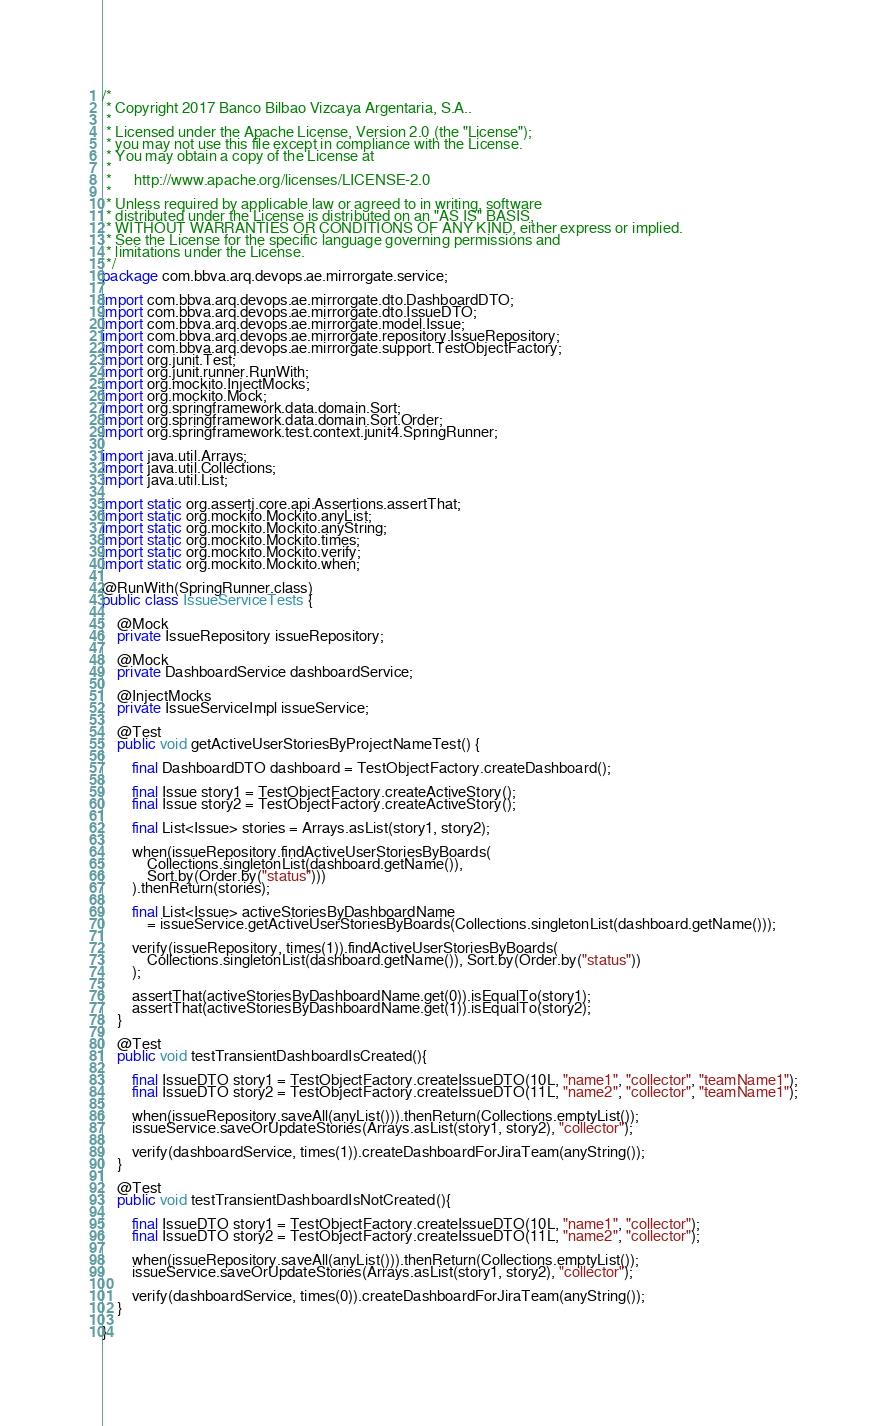<code> <loc_0><loc_0><loc_500><loc_500><_Java_>/*
 * Copyright 2017 Banco Bilbao Vizcaya Argentaria, S.A..
 *
 * Licensed under the Apache License, Version 2.0 (the "License");
 * you may not use this file except in compliance with the License.
 * You may obtain a copy of the License at
 *
 *      http://www.apache.org/licenses/LICENSE-2.0
 *
 * Unless required by applicable law or agreed to in writing, software
 * distributed under the License is distributed on an "AS IS" BASIS,
 * WITHOUT WARRANTIES OR CONDITIONS OF ANY KIND, either express or implied.
 * See the License for the specific language governing permissions and
 * limitations under the License.
 */
package com.bbva.arq.devops.ae.mirrorgate.service;

import com.bbva.arq.devops.ae.mirrorgate.dto.DashboardDTO;
import com.bbva.arq.devops.ae.mirrorgate.dto.IssueDTO;
import com.bbva.arq.devops.ae.mirrorgate.model.Issue;
import com.bbva.arq.devops.ae.mirrorgate.repository.IssueRepository;
import com.bbva.arq.devops.ae.mirrorgate.support.TestObjectFactory;
import org.junit.Test;
import org.junit.runner.RunWith;
import org.mockito.InjectMocks;
import org.mockito.Mock;
import org.springframework.data.domain.Sort;
import org.springframework.data.domain.Sort.Order;
import org.springframework.test.context.junit4.SpringRunner;

import java.util.Arrays;
import java.util.Collections;
import java.util.List;

import static org.assertj.core.api.Assertions.assertThat;
import static org.mockito.Mockito.anyList;
import static org.mockito.Mockito.anyString;
import static org.mockito.Mockito.times;
import static org.mockito.Mockito.verify;
import static org.mockito.Mockito.when;

@RunWith(SpringRunner.class)
public class IssueServiceTests {

    @Mock
    private IssueRepository issueRepository;

    @Mock
    private DashboardService dashboardService;

    @InjectMocks
    private IssueServiceImpl issueService;

    @Test
    public void getActiveUserStoriesByProjectNameTest() {

        final DashboardDTO dashboard = TestObjectFactory.createDashboard();

        final Issue story1 = TestObjectFactory.createActiveStory();
        final Issue story2 = TestObjectFactory.createActiveStory();

        final List<Issue> stories = Arrays.asList(story1, story2);

        when(issueRepository.findActiveUserStoriesByBoards(
            Collections.singletonList(dashboard.getName()),
            Sort.by(Order.by("status")))
        ).thenReturn(stories);

        final List<Issue> activeStoriesByDashboardName
            = issueService.getActiveUserStoriesByBoards(Collections.singletonList(dashboard.getName()));

        verify(issueRepository, times(1)).findActiveUserStoriesByBoards(
            Collections.singletonList(dashboard.getName()), Sort.by(Order.by("status"))
        );

        assertThat(activeStoriesByDashboardName.get(0)).isEqualTo(story1);
        assertThat(activeStoriesByDashboardName.get(1)).isEqualTo(story2);
    }

    @Test
    public void testTransientDashboardIsCreated(){

        final IssueDTO story1 = TestObjectFactory.createIssueDTO(10L, "name1", "collector", "teamName1");
        final IssueDTO story2 = TestObjectFactory.createIssueDTO(11L, "name2", "collector", "teamName1");

        when(issueRepository.saveAll(anyList())).thenReturn(Collections.emptyList());
        issueService.saveOrUpdateStories(Arrays.asList(story1, story2), "collector");

        verify(dashboardService, times(1)).createDashboardForJiraTeam(anyString());
    }

    @Test
    public void testTransientDashboardIsNotCreated(){

        final IssueDTO story1 = TestObjectFactory.createIssueDTO(10L, "name1", "collector");
        final IssueDTO story2 = TestObjectFactory.createIssueDTO(11L, "name2", "collector");

        when(issueRepository.saveAll(anyList())).thenReturn(Collections.emptyList());
        issueService.saveOrUpdateStories(Arrays.asList(story1, story2), "collector");

        verify(dashboardService, times(0)).createDashboardForJiraTeam(anyString());
    }

}
</code> 